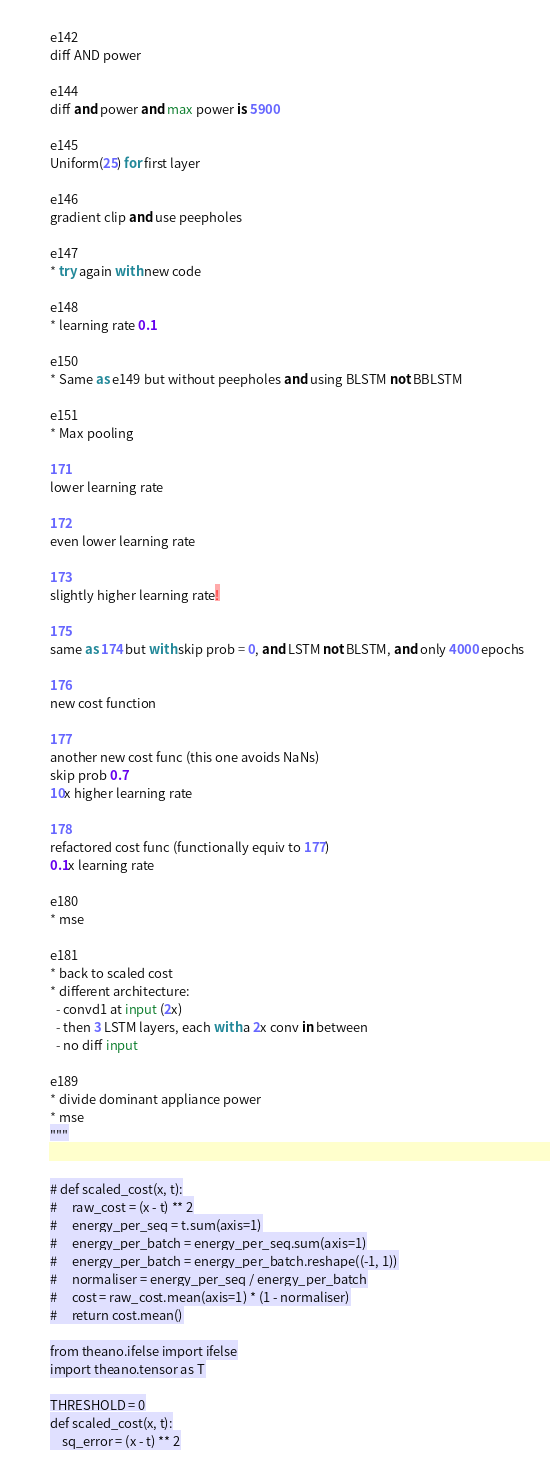<code> <loc_0><loc_0><loc_500><loc_500><_Python_>e142
diff AND power

e144
diff and power and max power is 5900

e145
Uniform(25) for first layer

e146
gradient clip and use peepholes

e147
* try again with new code

e148
* learning rate 0.1

e150
* Same as e149 but without peepholes and using BLSTM not BBLSTM

e151
* Max pooling

171
lower learning rate

172
even lower learning rate

173
slightly higher learning rate!

175
same as 174 but with skip prob = 0, and LSTM not BLSTM, and only 4000 epochs

176
new cost function

177
another new cost func (this one avoids NaNs)
skip prob 0.7
10x higher learning rate

178
refactored cost func (functionally equiv to 177)
0.1x learning rate

e180
* mse

e181
* back to scaled cost
* different architecture:
  - convd1 at input (2x)
  - then 3 LSTM layers, each with a 2x conv in between
  - no diff input

e189
* divide dominant appliance power
* mse
"""


# def scaled_cost(x, t):
#     raw_cost = (x - t) ** 2
#     energy_per_seq = t.sum(axis=1)
#     energy_per_batch = energy_per_seq.sum(axis=1)
#     energy_per_batch = energy_per_batch.reshape((-1, 1))
#     normaliser = energy_per_seq / energy_per_batch
#     cost = raw_cost.mean(axis=1) * (1 - normaliser)
#     return cost.mean()

from theano.ifelse import ifelse
import theano.tensor as T

THRESHOLD = 0
def scaled_cost(x, t):
    sq_error = (x - t) ** 2</code> 